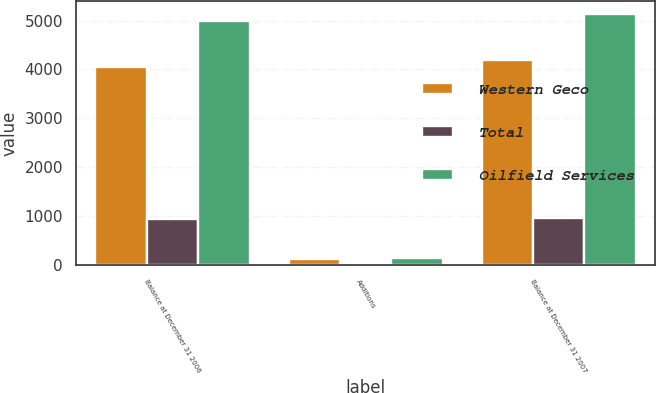<chart> <loc_0><loc_0><loc_500><loc_500><stacked_bar_chart><ecel><fcel>Balance at December 31 2006<fcel>Additions<fcel>Balance at December 31 2007<nl><fcel>Western Geco<fcel>4049<fcel>129<fcel>4185<nl><fcel>Total<fcel>940<fcel>17<fcel>957<nl><fcel>Oilfield Services<fcel>4989<fcel>146<fcel>5142<nl></chart> 